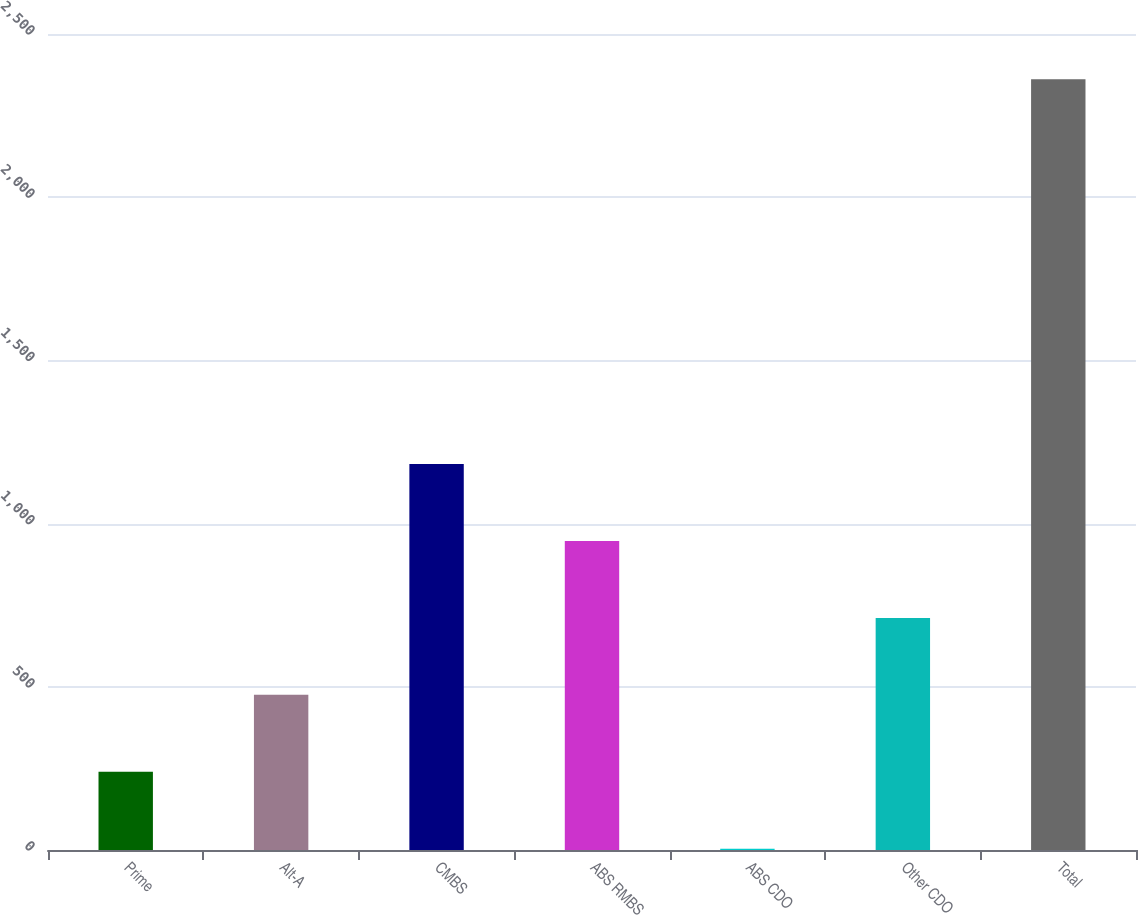Convert chart to OTSL. <chart><loc_0><loc_0><loc_500><loc_500><bar_chart><fcel>Prime<fcel>Alt-A<fcel>CMBS<fcel>ABS RMBS<fcel>ABS CDO<fcel>Other CDO<fcel>Total<nl><fcel>239.7<fcel>475.4<fcel>1182.5<fcel>946.8<fcel>4<fcel>711.1<fcel>2361<nl></chart> 